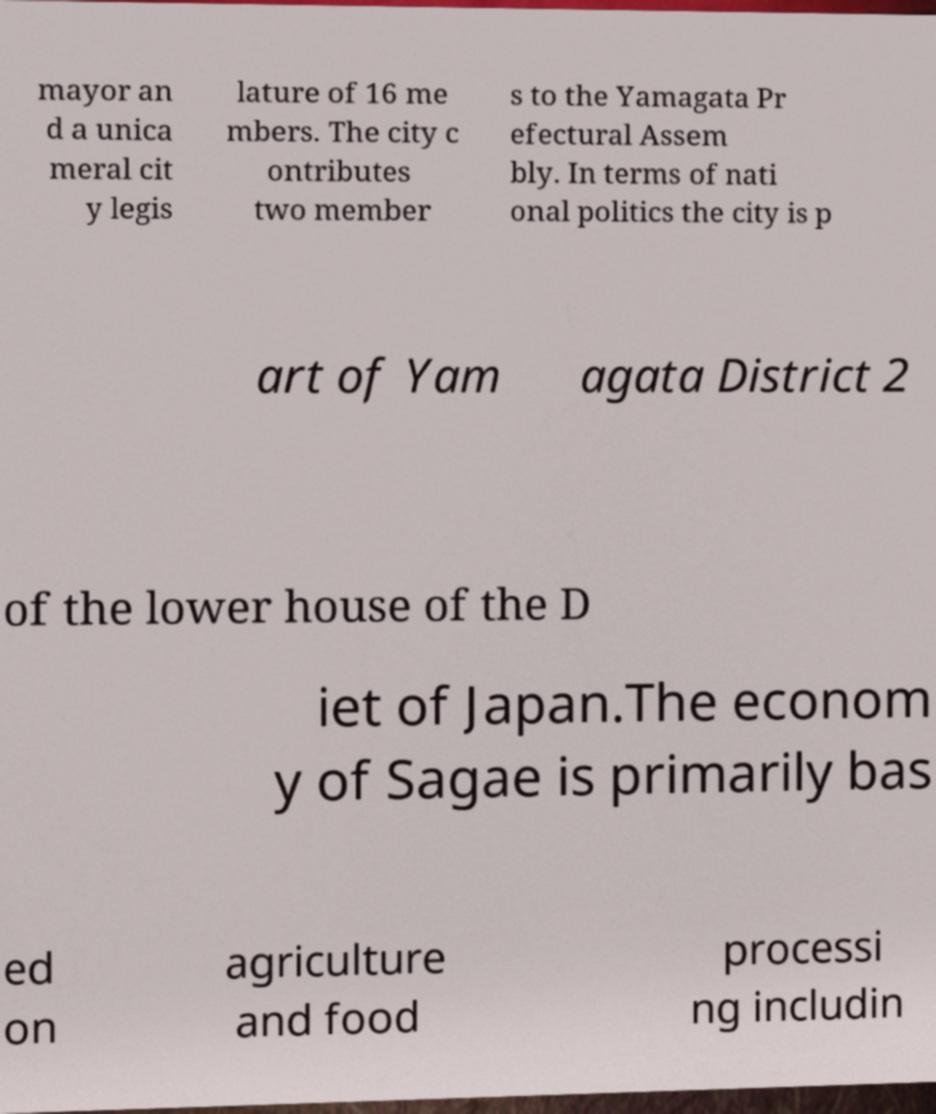Could you assist in decoding the text presented in this image and type it out clearly? mayor an d a unica meral cit y legis lature of 16 me mbers. The city c ontributes two member s to the Yamagata Pr efectural Assem bly. In terms of nati onal politics the city is p art of Yam agata District 2 of the lower house of the D iet of Japan.The econom y of Sagae is primarily bas ed on agriculture and food processi ng includin 